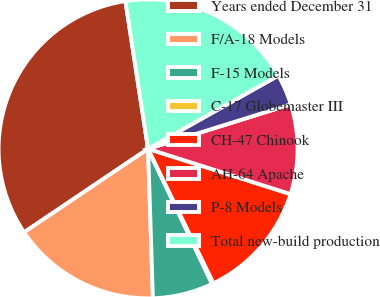<chart> <loc_0><loc_0><loc_500><loc_500><pie_chart><fcel>Years ended December 31<fcel>F/A-18 Models<fcel>F-15 Models<fcel>C-17 Globemaster III<fcel>CH-47 Chinook<fcel>AH-64 Apache<fcel>P-8 Models<fcel>Total new-build production<nl><fcel>32.01%<fcel>16.08%<fcel>6.53%<fcel>0.16%<fcel>12.9%<fcel>9.71%<fcel>3.34%<fcel>19.27%<nl></chart> 